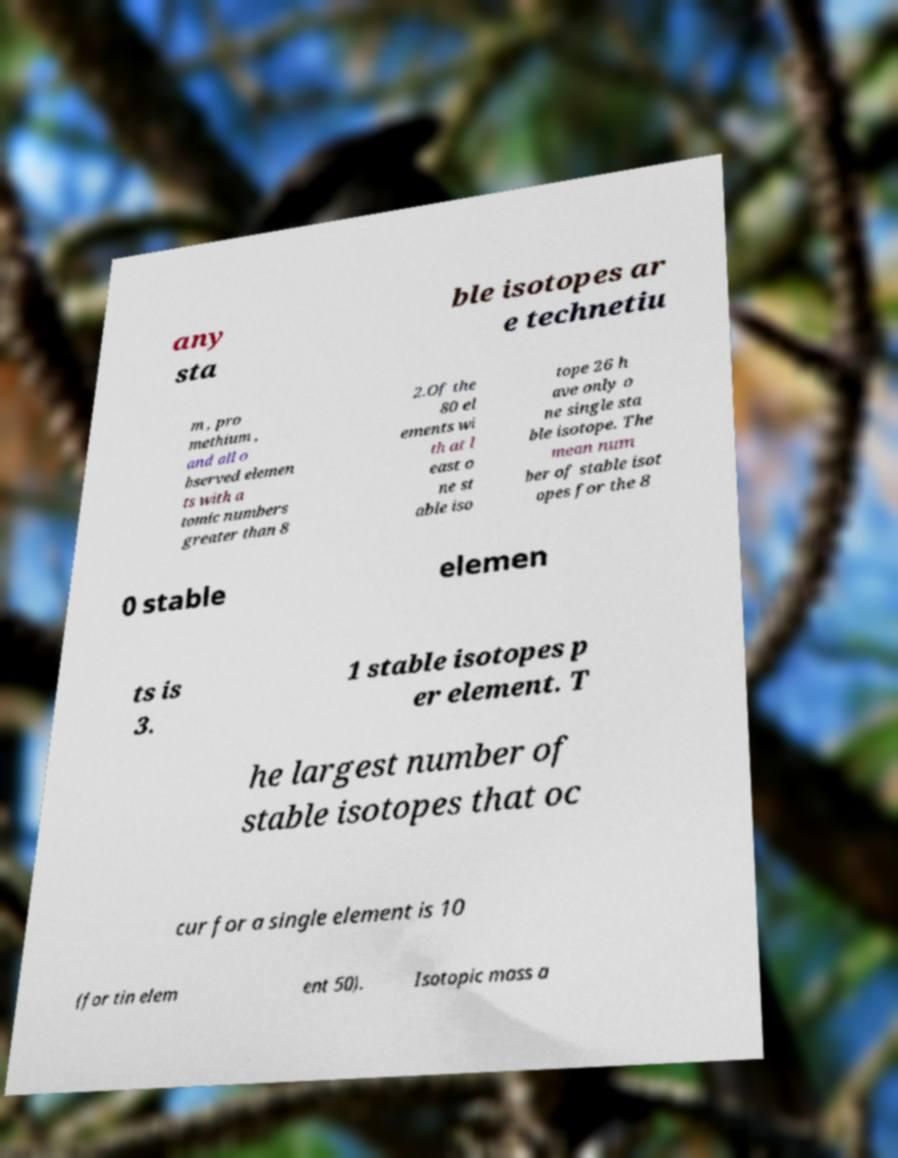Can you accurately transcribe the text from the provided image for me? any sta ble isotopes ar e technetiu m , pro methium , and all o bserved elemen ts with a tomic numbers greater than 8 2.Of the 80 el ements wi th at l east o ne st able iso tope 26 h ave only o ne single sta ble isotope. The mean num ber of stable isot opes for the 8 0 stable elemen ts is 3. 1 stable isotopes p er element. T he largest number of stable isotopes that oc cur for a single element is 10 (for tin elem ent 50). Isotopic mass a 